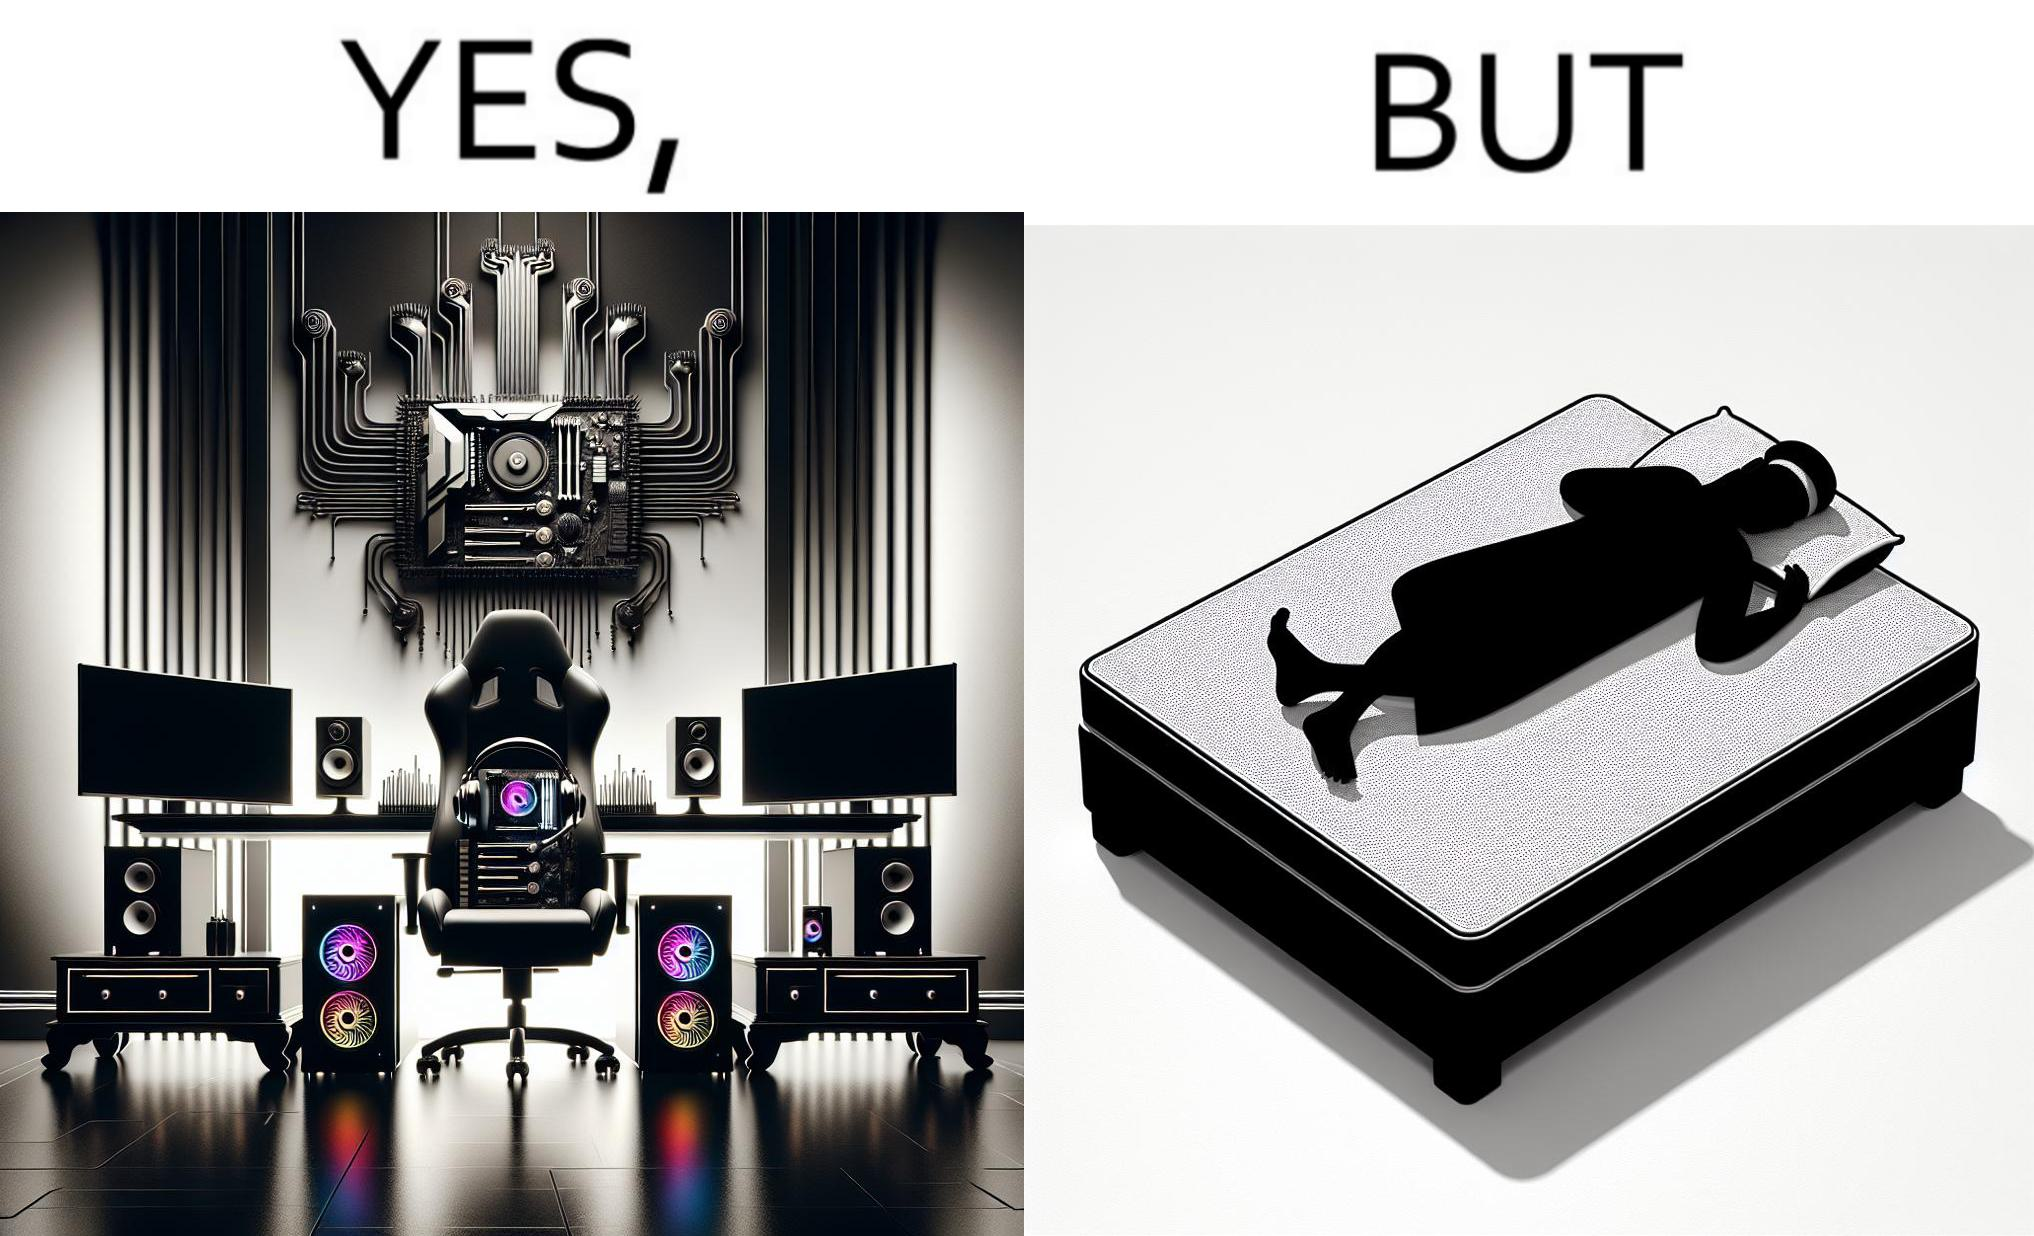Would you classify this image as satirical? Yes, this image is satirical. 